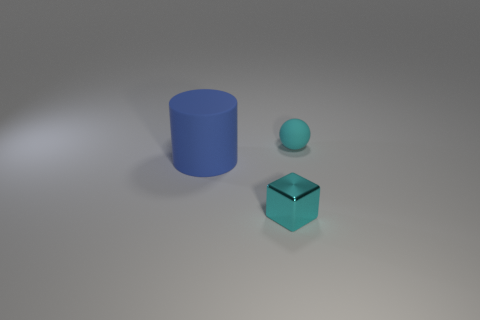Does the blue object have the same material as the tiny block?
Your response must be concise. No. What is the material of the blue object?
Provide a succinct answer. Rubber. What shape is the matte thing that is the same color as the small cube?
Your response must be concise. Sphere. Do the cyan object that is right of the block and the large blue cylinder that is to the left of the cyan matte sphere have the same material?
Your response must be concise. Yes. The small cyan object that is to the left of the cyan thing that is right of the tiny cyan block is what shape?
Provide a short and direct response. Cube. Are there any other things of the same color as the tiny matte sphere?
Your answer should be compact. Yes. There is a object to the left of the small object left of the tiny rubber sphere; are there any tiny balls behind it?
Your answer should be very brief. Yes. There is a tiny object that is in front of the small cyan rubber ball; does it have the same color as the matte thing that is behind the large blue rubber cylinder?
Your response must be concise. Yes. There is a cyan thing that is the same size as the cyan shiny cube; what material is it?
Your response must be concise. Rubber. What size is the thing in front of the thing left of the tiny shiny object that is on the right side of the big blue thing?
Your answer should be very brief. Small. 